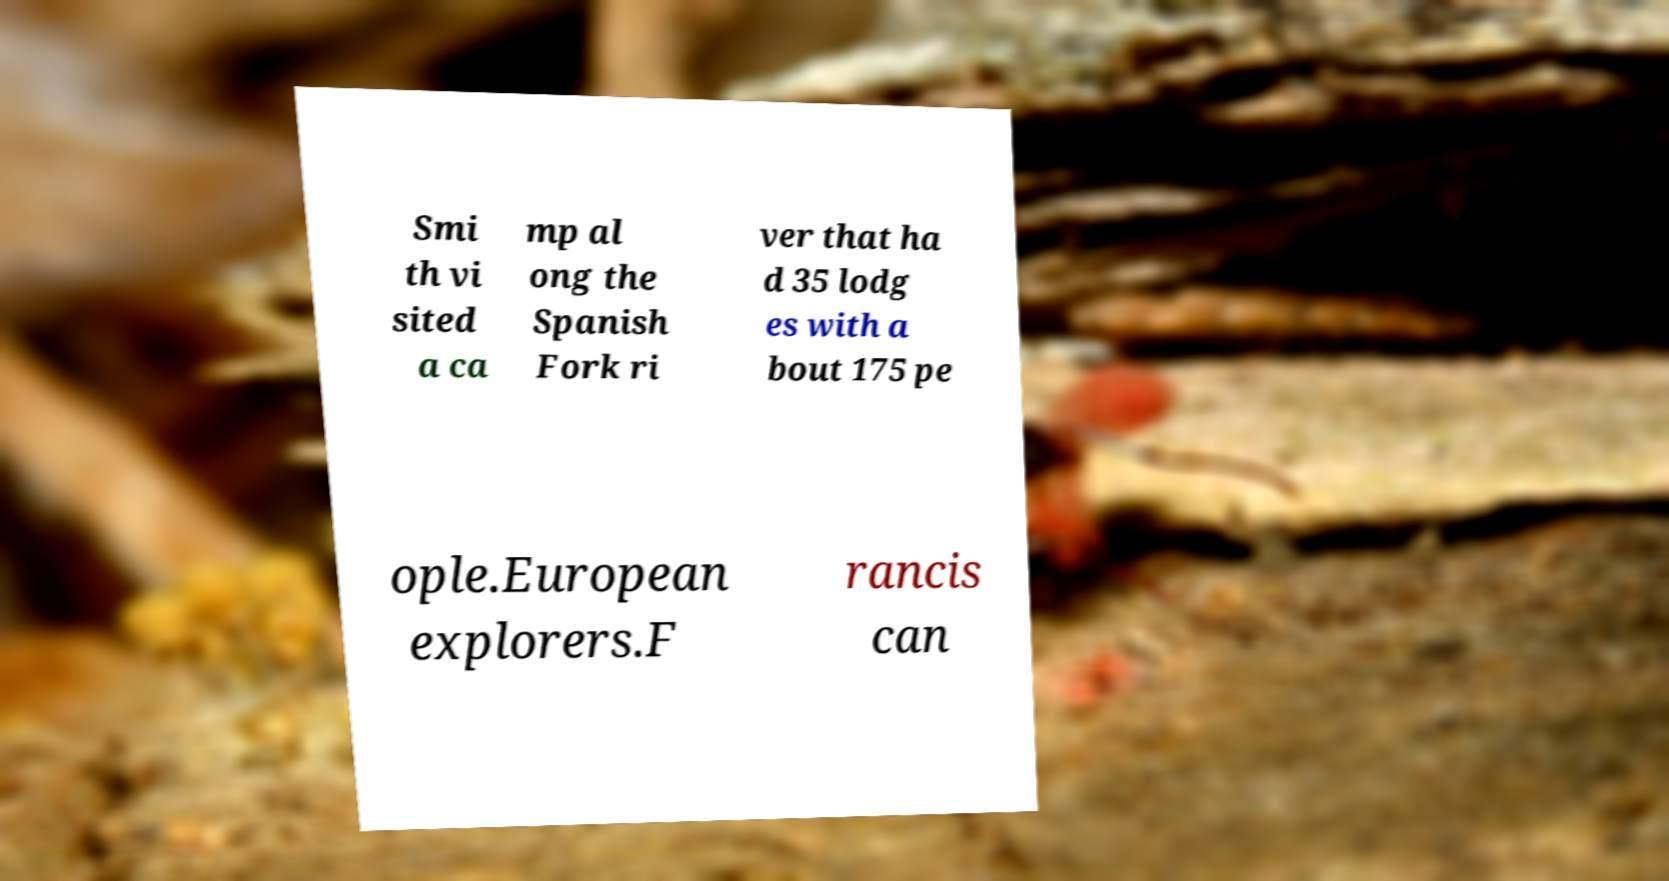Please identify and transcribe the text found in this image. Smi th vi sited a ca mp al ong the Spanish Fork ri ver that ha d 35 lodg es with a bout 175 pe ople.European explorers.F rancis can 